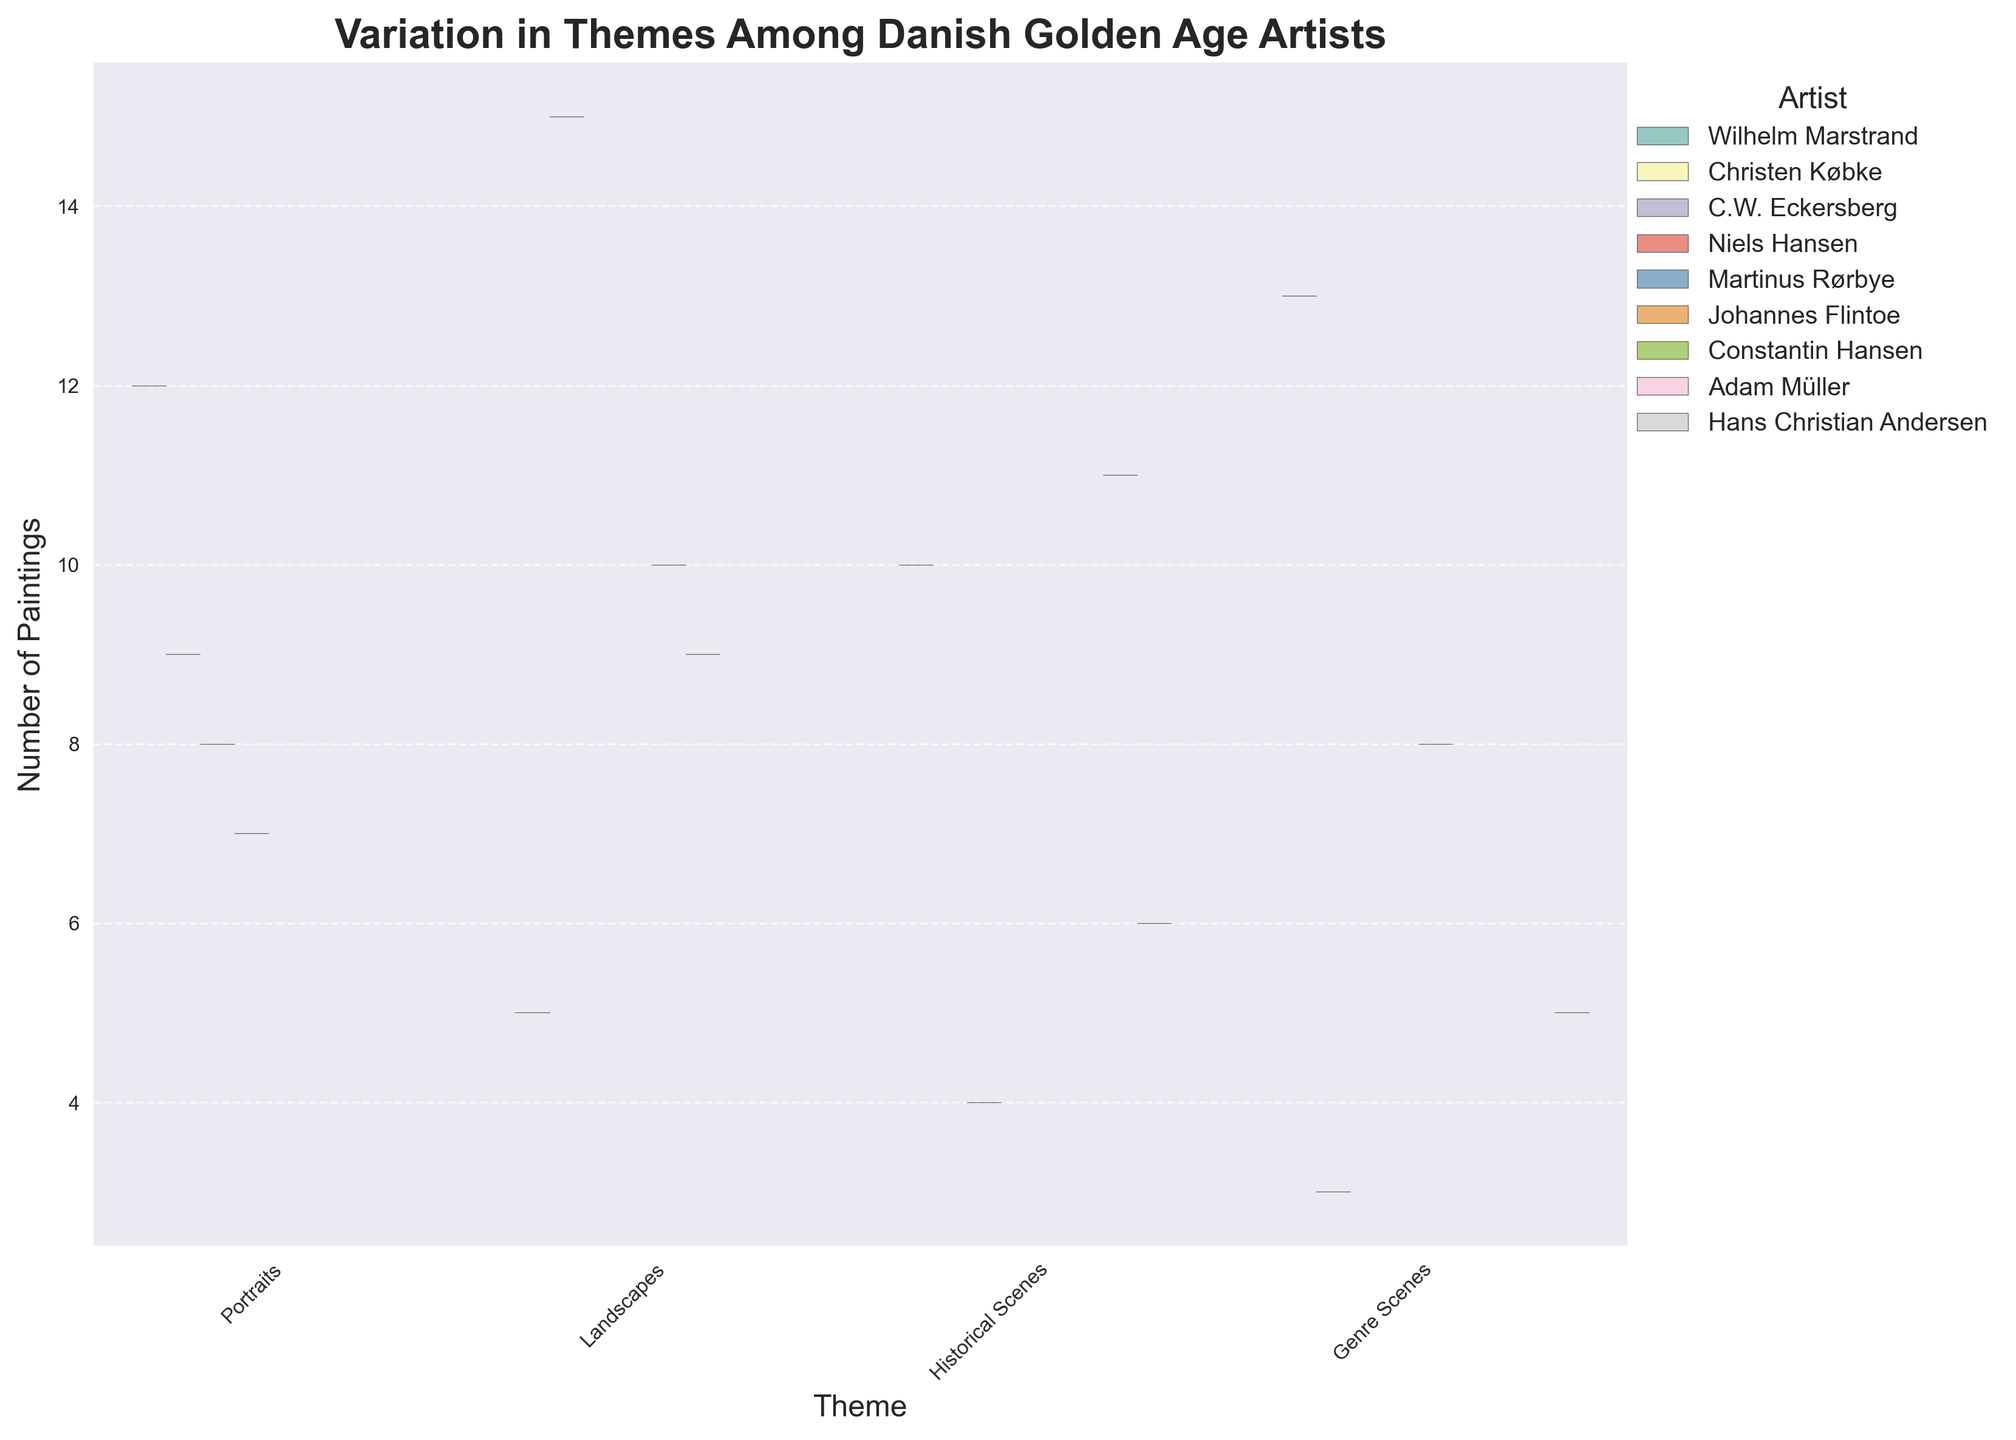What is the title of the chart? The title of the chart is always clearly displayed at the top. It provides a summary of what the chart represents.
Answer: Variation in Themes Among Danish Golden Age Artists What is the median number of paintings for the theme 'Landscapes'? To find the median number of paintings for Landscapes, we need to look at the center value in the vertical distribution of data points corresponding to Landscapes. Since there are 4 artists with values (5, 9, 10, 15), the median is the average of the two middle numbers: (9 + 10) / 2.
Answer: 9.5 Which artist has the highest number of portrait paintings? To answer this, we look at the violin plot for the 'Portraits' theme and identify the artist with the highest peak. Wilhelm Marstrand has the highest peak at 12 paintings.
Answer: Wilhelm Marstrand How many total landscape paintings are represented in the chart? Add the number of landscape paintings for all artists. The total is 5 (Marstrand) + 15 (Købke) + 10 (Rørbye) + 9 (Flintoe) = 39.
Answer: 39 Which theme shows the greatest variation in the number of paintings among the artists? The theme with the widest and most spread-out violin plot indicates the greatest variation. By visual inspection, 'Landscapes' show the greatest width and spread.
Answer: Landscapes How does Wilhelm Marstrand’s number of genre scenes compare to those of Hans Christian Andersen? Compare the values for both artists under the 'Genre Scenes' theme. Marstrand has 13 genre scenes, while Andersen has 5, so Marstrand has many more.
Answer: Marstrand has more What is the range of historical scene paintings for Wilhelm Marstrand and Constantin Hansen combined? The values for Marstrand and Hansen are 10 and 11 respectively. The range is found by subtracting the smallest value from the largest value: 11 - 10.
Answer: 1 Which artist has contributed the most across all themes combined? Sum the number of paintings for each artist in all themes. Wilhelm Marstrand: 12 + 5 + 10 + 13 = 40. He has the highest total number of paintings.
Answer: Wilhelm Marstrand How many themes did Christen Købke contribute to, and in which themes? Check the chart for the presence of Christen Købke in different themes. He is present in Portraits (9), Landscapes (15), and Genre Scenes (3).
Answer: 3 themes: Portraits, Landscapes, Genre Scenes 